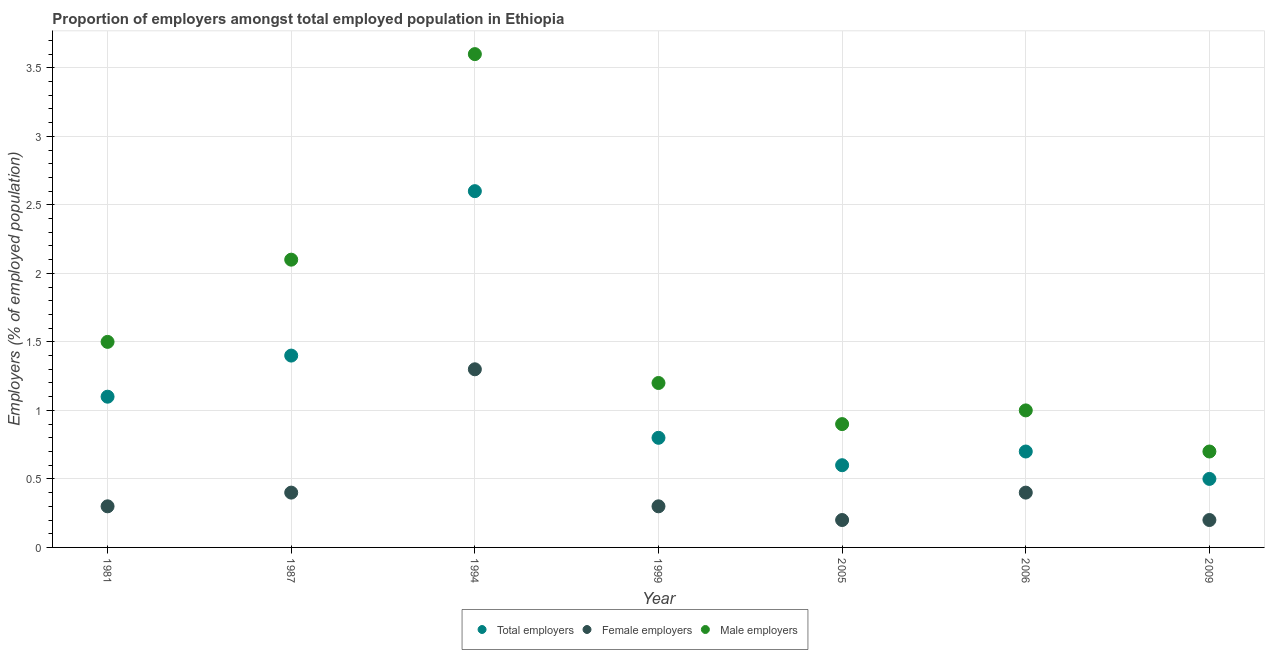Is the number of dotlines equal to the number of legend labels?
Offer a very short reply. Yes. Across all years, what is the maximum percentage of female employers?
Offer a very short reply. 1.3. Across all years, what is the minimum percentage of female employers?
Provide a short and direct response. 0.2. What is the total percentage of male employers in the graph?
Provide a succinct answer. 11. What is the difference between the percentage of female employers in 1981 and that in 2005?
Give a very brief answer. 0.1. What is the difference between the percentage of total employers in 1994 and the percentage of male employers in 1999?
Make the answer very short. 1.4. What is the average percentage of male employers per year?
Give a very brief answer. 1.57. In the year 1994, what is the difference between the percentage of female employers and percentage of male employers?
Offer a very short reply. -2.3. What is the ratio of the percentage of male employers in 1981 to that in 1994?
Ensure brevity in your answer.  0.42. Is the percentage of male employers in 1999 less than that in 2009?
Your answer should be very brief. No. Is the difference between the percentage of male employers in 1981 and 2006 greater than the difference between the percentage of total employers in 1981 and 2006?
Keep it short and to the point. Yes. What is the difference between the highest and the second highest percentage of female employers?
Your answer should be compact. 0.9. What is the difference between the highest and the lowest percentage of male employers?
Provide a succinct answer. 2.9. Is it the case that in every year, the sum of the percentage of total employers and percentage of female employers is greater than the percentage of male employers?
Your answer should be compact. No. Is the percentage of female employers strictly greater than the percentage of male employers over the years?
Your answer should be compact. No. Is the percentage of male employers strictly less than the percentage of female employers over the years?
Ensure brevity in your answer.  No. Does the graph contain grids?
Provide a short and direct response. Yes. How are the legend labels stacked?
Offer a very short reply. Horizontal. What is the title of the graph?
Offer a very short reply. Proportion of employers amongst total employed population in Ethiopia. What is the label or title of the Y-axis?
Ensure brevity in your answer.  Employers (% of employed population). What is the Employers (% of employed population) of Total employers in 1981?
Your answer should be compact. 1.1. What is the Employers (% of employed population) of Female employers in 1981?
Your response must be concise. 0.3. What is the Employers (% of employed population) of Total employers in 1987?
Make the answer very short. 1.4. What is the Employers (% of employed population) in Female employers in 1987?
Your response must be concise. 0.4. What is the Employers (% of employed population) of Male employers in 1987?
Provide a succinct answer. 2.1. What is the Employers (% of employed population) in Total employers in 1994?
Your response must be concise. 2.6. What is the Employers (% of employed population) in Female employers in 1994?
Provide a succinct answer. 1.3. What is the Employers (% of employed population) of Male employers in 1994?
Ensure brevity in your answer.  3.6. What is the Employers (% of employed population) in Total employers in 1999?
Ensure brevity in your answer.  0.8. What is the Employers (% of employed population) in Female employers in 1999?
Provide a short and direct response. 0.3. What is the Employers (% of employed population) in Male employers in 1999?
Provide a succinct answer. 1.2. What is the Employers (% of employed population) of Total employers in 2005?
Your answer should be very brief. 0.6. What is the Employers (% of employed population) of Female employers in 2005?
Your response must be concise. 0.2. What is the Employers (% of employed population) of Male employers in 2005?
Provide a short and direct response. 0.9. What is the Employers (% of employed population) of Total employers in 2006?
Give a very brief answer. 0.7. What is the Employers (% of employed population) of Female employers in 2006?
Your answer should be very brief. 0.4. What is the Employers (% of employed population) in Male employers in 2006?
Keep it short and to the point. 1. What is the Employers (% of employed population) in Total employers in 2009?
Offer a very short reply. 0.5. What is the Employers (% of employed population) in Female employers in 2009?
Your answer should be compact. 0.2. What is the Employers (% of employed population) in Male employers in 2009?
Your answer should be very brief. 0.7. Across all years, what is the maximum Employers (% of employed population) of Total employers?
Keep it short and to the point. 2.6. Across all years, what is the maximum Employers (% of employed population) in Female employers?
Ensure brevity in your answer.  1.3. Across all years, what is the maximum Employers (% of employed population) of Male employers?
Your answer should be compact. 3.6. Across all years, what is the minimum Employers (% of employed population) in Female employers?
Your answer should be compact. 0.2. Across all years, what is the minimum Employers (% of employed population) of Male employers?
Offer a very short reply. 0.7. What is the total Employers (% of employed population) of Female employers in the graph?
Keep it short and to the point. 3.1. What is the total Employers (% of employed population) in Male employers in the graph?
Your response must be concise. 11. What is the difference between the Employers (% of employed population) in Total employers in 1981 and that in 1987?
Give a very brief answer. -0.3. What is the difference between the Employers (% of employed population) in Female employers in 1981 and that in 1987?
Keep it short and to the point. -0.1. What is the difference between the Employers (% of employed population) of Male employers in 1981 and that in 1987?
Provide a succinct answer. -0.6. What is the difference between the Employers (% of employed population) of Total employers in 1981 and that in 1994?
Keep it short and to the point. -1.5. What is the difference between the Employers (% of employed population) of Female employers in 1981 and that in 1994?
Make the answer very short. -1. What is the difference between the Employers (% of employed population) of Female employers in 1981 and that in 1999?
Keep it short and to the point. 0. What is the difference between the Employers (% of employed population) in Male employers in 1981 and that in 1999?
Give a very brief answer. 0.3. What is the difference between the Employers (% of employed population) in Male employers in 1981 and that in 2005?
Provide a short and direct response. 0.6. What is the difference between the Employers (% of employed population) in Female employers in 1981 and that in 2006?
Your answer should be compact. -0.1. What is the difference between the Employers (% of employed population) in Male employers in 1987 and that in 1994?
Offer a very short reply. -1.5. What is the difference between the Employers (% of employed population) of Female employers in 1987 and that in 1999?
Provide a short and direct response. 0.1. What is the difference between the Employers (% of employed population) of Male employers in 1987 and that in 2006?
Your response must be concise. 1.1. What is the difference between the Employers (% of employed population) of Total employers in 1987 and that in 2009?
Keep it short and to the point. 0.9. What is the difference between the Employers (% of employed population) in Female employers in 1987 and that in 2009?
Your response must be concise. 0.2. What is the difference between the Employers (% of employed population) of Male employers in 1987 and that in 2009?
Your response must be concise. 1.4. What is the difference between the Employers (% of employed population) of Total employers in 1994 and that in 1999?
Your answer should be very brief. 1.8. What is the difference between the Employers (% of employed population) in Female employers in 1994 and that in 1999?
Keep it short and to the point. 1. What is the difference between the Employers (% of employed population) in Male employers in 1994 and that in 1999?
Offer a terse response. 2.4. What is the difference between the Employers (% of employed population) of Male employers in 1994 and that in 2006?
Ensure brevity in your answer.  2.6. What is the difference between the Employers (% of employed population) in Male employers in 1994 and that in 2009?
Ensure brevity in your answer.  2.9. What is the difference between the Employers (% of employed population) in Female employers in 1999 and that in 2005?
Offer a terse response. 0.1. What is the difference between the Employers (% of employed population) in Male employers in 1999 and that in 2005?
Make the answer very short. 0.3. What is the difference between the Employers (% of employed population) of Female employers in 1999 and that in 2006?
Provide a short and direct response. -0.1. What is the difference between the Employers (% of employed population) of Total employers in 1999 and that in 2009?
Your answer should be compact. 0.3. What is the difference between the Employers (% of employed population) of Male employers in 1999 and that in 2009?
Ensure brevity in your answer.  0.5. What is the difference between the Employers (% of employed population) of Total employers in 1981 and the Employers (% of employed population) of Female employers in 1987?
Make the answer very short. 0.7. What is the difference between the Employers (% of employed population) of Total employers in 1981 and the Employers (% of employed population) of Male employers in 1987?
Ensure brevity in your answer.  -1. What is the difference between the Employers (% of employed population) in Female employers in 1981 and the Employers (% of employed population) in Male employers in 1987?
Your answer should be very brief. -1.8. What is the difference between the Employers (% of employed population) of Total employers in 1981 and the Employers (% of employed population) of Male employers in 1994?
Your answer should be compact. -2.5. What is the difference between the Employers (% of employed population) of Total employers in 1981 and the Employers (% of employed population) of Male employers in 1999?
Provide a short and direct response. -0.1. What is the difference between the Employers (% of employed population) of Total employers in 1981 and the Employers (% of employed population) of Female employers in 2005?
Your answer should be very brief. 0.9. What is the difference between the Employers (% of employed population) of Female employers in 1987 and the Employers (% of employed population) of Male employers in 1994?
Provide a succinct answer. -3.2. What is the difference between the Employers (% of employed population) in Total employers in 1987 and the Employers (% of employed population) in Female employers in 1999?
Keep it short and to the point. 1.1. What is the difference between the Employers (% of employed population) in Total employers in 1987 and the Employers (% of employed population) in Male employers in 1999?
Keep it short and to the point. 0.2. What is the difference between the Employers (% of employed population) of Female employers in 1987 and the Employers (% of employed population) of Male employers in 1999?
Give a very brief answer. -0.8. What is the difference between the Employers (% of employed population) in Total employers in 1987 and the Employers (% of employed population) in Female employers in 2005?
Provide a short and direct response. 1.2. What is the difference between the Employers (% of employed population) of Total employers in 1987 and the Employers (% of employed population) of Male employers in 2005?
Make the answer very short. 0.5. What is the difference between the Employers (% of employed population) of Female employers in 1987 and the Employers (% of employed population) of Male employers in 2006?
Your answer should be very brief. -0.6. What is the difference between the Employers (% of employed population) in Total employers in 1987 and the Employers (% of employed population) in Male employers in 2009?
Give a very brief answer. 0.7. What is the difference between the Employers (% of employed population) in Female employers in 1987 and the Employers (% of employed population) in Male employers in 2009?
Make the answer very short. -0.3. What is the difference between the Employers (% of employed population) in Total employers in 1994 and the Employers (% of employed population) in Male employers in 1999?
Give a very brief answer. 1.4. What is the difference between the Employers (% of employed population) in Total employers in 1994 and the Employers (% of employed population) in Female employers in 2005?
Offer a terse response. 2.4. What is the difference between the Employers (% of employed population) in Total employers in 1994 and the Employers (% of employed population) in Male employers in 2005?
Ensure brevity in your answer.  1.7. What is the difference between the Employers (% of employed population) in Total employers in 1994 and the Employers (% of employed population) in Female employers in 2006?
Ensure brevity in your answer.  2.2. What is the difference between the Employers (% of employed population) of Total employers in 1994 and the Employers (% of employed population) of Male employers in 2006?
Your answer should be compact. 1.6. What is the difference between the Employers (% of employed population) in Female employers in 1999 and the Employers (% of employed population) in Male employers in 2005?
Your response must be concise. -0.6. What is the difference between the Employers (% of employed population) in Total employers in 1999 and the Employers (% of employed population) in Female employers in 2006?
Ensure brevity in your answer.  0.4. What is the difference between the Employers (% of employed population) of Total employers in 2005 and the Employers (% of employed population) of Female employers in 2006?
Provide a succinct answer. 0.2. What is the difference between the Employers (% of employed population) in Total employers in 2005 and the Employers (% of employed population) in Male employers in 2006?
Provide a short and direct response. -0.4. What is the difference between the Employers (% of employed population) in Total employers in 2005 and the Employers (% of employed population) in Female employers in 2009?
Your answer should be compact. 0.4. What is the difference between the Employers (% of employed population) in Total employers in 2005 and the Employers (% of employed population) in Male employers in 2009?
Keep it short and to the point. -0.1. What is the difference between the Employers (% of employed population) in Female employers in 2005 and the Employers (% of employed population) in Male employers in 2009?
Make the answer very short. -0.5. What is the average Employers (% of employed population) in Female employers per year?
Offer a terse response. 0.44. What is the average Employers (% of employed population) of Male employers per year?
Offer a very short reply. 1.57. In the year 1994, what is the difference between the Employers (% of employed population) of Total employers and Employers (% of employed population) of Male employers?
Ensure brevity in your answer.  -1. In the year 1994, what is the difference between the Employers (% of employed population) of Female employers and Employers (% of employed population) of Male employers?
Ensure brevity in your answer.  -2.3. In the year 1999, what is the difference between the Employers (% of employed population) in Total employers and Employers (% of employed population) in Male employers?
Provide a succinct answer. -0.4. In the year 1999, what is the difference between the Employers (% of employed population) of Female employers and Employers (% of employed population) of Male employers?
Your answer should be very brief. -0.9. In the year 2005, what is the difference between the Employers (% of employed population) in Total employers and Employers (% of employed population) in Female employers?
Provide a succinct answer. 0.4. In the year 2005, what is the difference between the Employers (% of employed population) of Female employers and Employers (% of employed population) of Male employers?
Make the answer very short. -0.7. In the year 2006, what is the difference between the Employers (% of employed population) of Total employers and Employers (% of employed population) of Female employers?
Give a very brief answer. 0.3. In the year 2006, what is the difference between the Employers (% of employed population) in Total employers and Employers (% of employed population) in Male employers?
Provide a short and direct response. -0.3. What is the ratio of the Employers (% of employed population) in Total employers in 1981 to that in 1987?
Offer a terse response. 0.79. What is the ratio of the Employers (% of employed population) in Male employers in 1981 to that in 1987?
Provide a succinct answer. 0.71. What is the ratio of the Employers (% of employed population) of Total employers in 1981 to that in 1994?
Offer a very short reply. 0.42. What is the ratio of the Employers (% of employed population) of Female employers in 1981 to that in 1994?
Offer a terse response. 0.23. What is the ratio of the Employers (% of employed population) in Male employers in 1981 to that in 1994?
Keep it short and to the point. 0.42. What is the ratio of the Employers (% of employed population) of Total employers in 1981 to that in 1999?
Give a very brief answer. 1.38. What is the ratio of the Employers (% of employed population) of Female employers in 1981 to that in 1999?
Your response must be concise. 1. What is the ratio of the Employers (% of employed population) in Total employers in 1981 to that in 2005?
Keep it short and to the point. 1.83. What is the ratio of the Employers (% of employed population) in Female employers in 1981 to that in 2005?
Offer a very short reply. 1.5. What is the ratio of the Employers (% of employed population) in Total employers in 1981 to that in 2006?
Offer a very short reply. 1.57. What is the ratio of the Employers (% of employed population) of Male employers in 1981 to that in 2006?
Provide a succinct answer. 1.5. What is the ratio of the Employers (% of employed population) of Total employers in 1981 to that in 2009?
Your answer should be compact. 2.2. What is the ratio of the Employers (% of employed population) in Male employers in 1981 to that in 2009?
Your answer should be compact. 2.14. What is the ratio of the Employers (% of employed population) of Total employers in 1987 to that in 1994?
Ensure brevity in your answer.  0.54. What is the ratio of the Employers (% of employed population) in Female employers in 1987 to that in 1994?
Make the answer very short. 0.31. What is the ratio of the Employers (% of employed population) of Male employers in 1987 to that in 1994?
Give a very brief answer. 0.58. What is the ratio of the Employers (% of employed population) in Total employers in 1987 to that in 2005?
Offer a very short reply. 2.33. What is the ratio of the Employers (% of employed population) of Male employers in 1987 to that in 2005?
Your response must be concise. 2.33. What is the ratio of the Employers (% of employed population) of Male employers in 1987 to that in 2006?
Offer a terse response. 2.1. What is the ratio of the Employers (% of employed population) in Female employers in 1987 to that in 2009?
Keep it short and to the point. 2. What is the ratio of the Employers (% of employed population) in Total employers in 1994 to that in 1999?
Keep it short and to the point. 3.25. What is the ratio of the Employers (% of employed population) in Female employers in 1994 to that in 1999?
Provide a short and direct response. 4.33. What is the ratio of the Employers (% of employed population) in Total employers in 1994 to that in 2005?
Offer a terse response. 4.33. What is the ratio of the Employers (% of employed population) of Female employers in 1994 to that in 2005?
Ensure brevity in your answer.  6.5. What is the ratio of the Employers (% of employed population) of Male employers in 1994 to that in 2005?
Make the answer very short. 4. What is the ratio of the Employers (% of employed population) of Total employers in 1994 to that in 2006?
Offer a very short reply. 3.71. What is the ratio of the Employers (% of employed population) in Total employers in 1994 to that in 2009?
Your response must be concise. 5.2. What is the ratio of the Employers (% of employed population) in Female employers in 1994 to that in 2009?
Offer a terse response. 6.5. What is the ratio of the Employers (% of employed population) of Male employers in 1994 to that in 2009?
Give a very brief answer. 5.14. What is the ratio of the Employers (% of employed population) in Total employers in 1999 to that in 2005?
Provide a succinct answer. 1.33. What is the ratio of the Employers (% of employed population) in Male employers in 1999 to that in 2005?
Your answer should be very brief. 1.33. What is the ratio of the Employers (% of employed population) of Male employers in 1999 to that in 2006?
Your response must be concise. 1.2. What is the ratio of the Employers (% of employed population) in Male employers in 1999 to that in 2009?
Your response must be concise. 1.71. What is the ratio of the Employers (% of employed population) of Female employers in 2005 to that in 2009?
Offer a very short reply. 1. What is the ratio of the Employers (% of employed population) of Male employers in 2005 to that in 2009?
Make the answer very short. 1.29. What is the ratio of the Employers (% of employed population) of Male employers in 2006 to that in 2009?
Your answer should be very brief. 1.43. What is the difference between the highest and the second highest Employers (% of employed population) of Total employers?
Make the answer very short. 1.2. What is the difference between the highest and the second highest Employers (% of employed population) in Female employers?
Keep it short and to the point. 0.9. What is the difference between the highest and the second highest Employers (% of employed population) of Male employers?
Keep it short and to the point. 1.5. What is the difference between the highest and the lowest Employers (% of employed population) of Female employers?
Give a very brief answer. 1.1. 